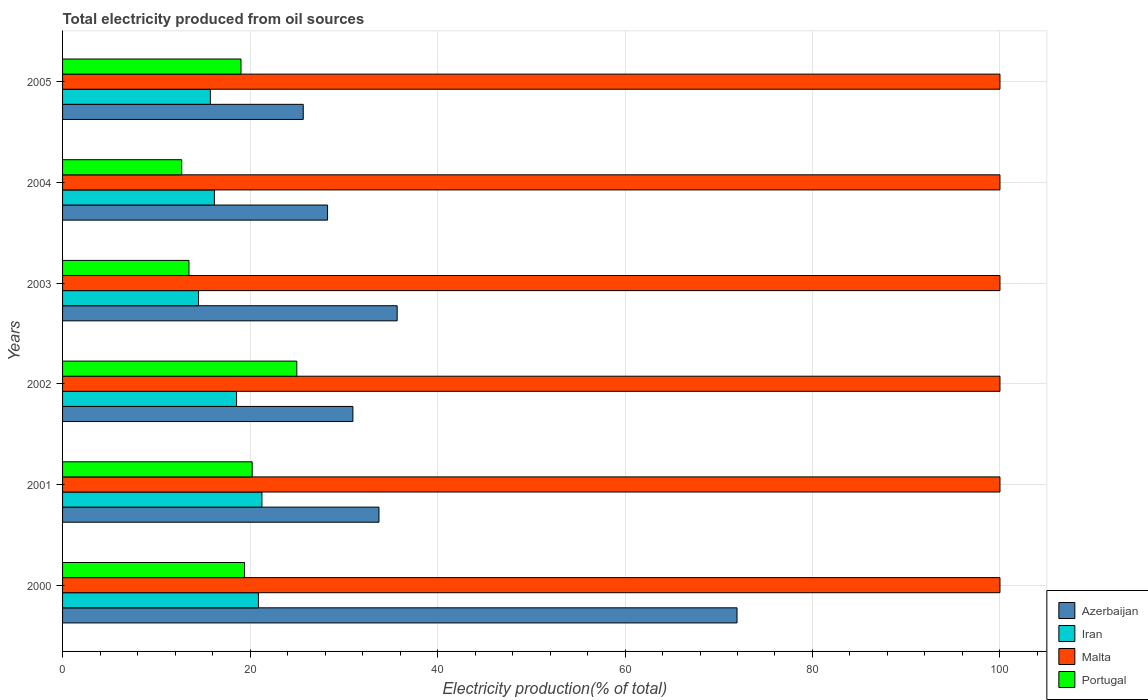How many different coloured bars are there?
Provide a succinct answer. 4. Are the number of bars per tick equal to the number of legend labels?
Offer a terse response. Yes. How many bars are there on the 5th tick from the top?
Provide a succinct answer. 4. In how many cases, is the number of bars for a given year not equal to the number of legend labels?
Your answer should be very brief. 0. What is the total electricity produced in Malta in 2004?
Offer a terse response. 100. Across all years, what is the maximum total electricity produced in Azerbaijan?
Offer a very short reply. 71.95. Across all years, what is the minimum total electricity produced in Malta?
Give a very brief answer. 100. In which year was the total electricity produced in Malta minimum?
Offer a terse response. 2000. What is the total total electricity produced in Malta in the graph?
Offer a very short reply. 600. What is the difference between the total electricity produced in Iran in 2002 and that in 2005?
Give a very brief answer. 2.8. What is the difference between the total electricity produced in Azerbaijan in 2003 and the total electricity produced in Iran in 2002?
Keep it short and to the point. 17.13. What is the average total electricity produced in Iran per year?
Provide a short and direct response. 17.87. In the year 2004, what is the difference between the total electricity produced in Portugal and total electricity produced in Malta?
Give a very brief answer. -87.29. In how many years, is the total electricity produced in Iran greater than 84 %?
Offer a very short reply. 0. What is the ratio of the total electricity produced in Portugal in 2001 to that in 2002?
Your answer should be compact. 0.81. What is the difference between the highest and the second highest total electricity produced in Malta?
Offer a terse response. 0. What is the difference between the highest and the lowest total electricity produced in Portugal?
Provide a succinct answer. 12.28. In how many years, is the total electricity produced in Portugal greater than the average total electricity produced in Portugal taken over all years?
Offer a very short reply. 4. Is the sum of the total electricity produced in Iran in 2000 and 2004 greater than the maximum total electricity produced in Malta across all years?
Give a very brief answer. No. Is it the case that in every year, the sum of the total electricity produced in Portugal and total electricity produced in Azerbaijan is greater than the sum of total electricity produced in Malta and total electricity produced in Iran?
Offer a very short reply. No. What does the 4th bar from the top in 2002 represents?
Ensure brevity in your answer.  Azerbaijan. What does the 1st bar from the bottom in 2002 represents?
Offer a terse response. Azerbaijan. Is it the case that in every year, the sum of the total electricity produced in Portugal and total electricity produced in Malta is greater than the total electricity produced in Azerbaijan?
Offer a very short reply. Yes. How many years are there in the graph?
Make the answer very short. 6. What is the difference between two consecutive major ticks on the X-axis?
Give a very brief answer. 20. Are the values on the major ticks of X-axis written in scientific E-notation?
Your response must be concise. No. Does the graph contain any zero values?
Provide a succinct answer. No. Does the graph contain grids?
Provide a short and direct response. Yes. How many legend labels are there?
Your answer should be compact. 4. What is the title of the graph?
Keep it short and to the point. Total electricity produced from oil sources. Does "High income: nonOECD" appear as one of the legend labels in the graph?
Offer a very short reply. No. What is the Electricity production(% of total) in Azerbaijan in 2000?
Make the answer very short. 71.95. What is the Electricity production(% of total) of Iran in 2000?
Offer a very short reply. 20.89. What is the Electricity production(% of total) of Portugal in 2000?
Your answer should be very brief. 19.42. What is the Electricity production(% of total) of Azerbaijan in 2001?
Your response must be concise. 33.75. What is the Electricity production(% of total) of Iran in 2001?
Your answer should be compact. 21.27. What is the Electricity production(% of total) in Malta in 2001?
Provide a short and direct response. 100. What is the Electricity production(% of total) in Portugal in 2001?
Give a very brief answer. 20.23. What is the Electricity production(% of total) in Azerbaijan in 2002?
Make the answer very short. 30.97. What is the Electricity production(% of total) of Iran in 2002?
Keep it short and to the point. 18.56. What is the Electricity production(% of total) in Malta in 2002?
Give a very brief answer. 100. What is the Electricity production(% of total) in Portugal in 2002?
Your answer should be very brief. 24.99. What is the Electricity production(% of total) in Azerbaijan in 2003?
Make the answer very short. 35.69. What is the Electricity production(% of total) of Iran in 2003?
Provide a short and direct response. 14.5. What is the Electricity production(% of total) of Malta in 2003?
Provide a short and direct response. 100. What is the Electricity production(% of total) of Portugal in 2003?
Make the answer very short. 13.48. What is the Electricity production(% of total) in Azerbaijan in 2004?
Give a very brief answer. 28.27. What is the Electricity production(% of total) of Iran in 2004?
Provide a succinct answer. 16.2. What is the Electricity production(% of total) in Portugal in 2004?
Give a very brief answer. 12.71. What is the Electricity production(% of total) of Azerbaijan in 2005?
Offer a terse response. 25.67. What is the Electricity production(% of total) in Iran in 2005?
Provide a short and direct response. 15.77. What is the Electricity production(% of total) in Malta in 2005?
Your answer should be compact. 100. What is the Electricity production(% of total) in Portugal in 2005?
Keep it short and to the point. 19.03. Across all years, what is the maximum Electricity production(% of total) in Azerbaijan?
Offer a very short reply. 71.95. Across all years, what is the maximum Electricity production(% of total) of Iran?
Provide a short and direct response. 21.27. Across all years, what is the maximum Electricity production(% of total) of Portugal?
Make the answer very short. 24.99. Across all years, what is the minimum Electricity production(% of total) of Azerbaijan?
Offer a terse response. 25.67. Across all years, what is the minimum Electricity production(% of total) of Iran?
Give a very brief answer. 14.5. Across all years, what is the minimum Electricity production(% of total) in Portugal?
Offer a very short reply. 12.71. What is the total Electricity production(% of total) of Azerbaijan in the graph?
Keep it short and to the point. 226.31. What is the total Electricity production(% of total) of Iran in the graph?
Make the answer very short. 107.19. What is the total Electricity production(% of total) in Malta in the graph?
Provide a short and direct response. 600. What is the total Electricity production(% of total) of Portugal in the graph?
Offer a terse response. 109.86. What is the difference between the Electricity production(% of total) in Azerbaijan in 2000 and that in 2001?
Your answer should be compact. 38.2. What is the difference between the Electricity production(% of total) in Iran in 2000 and that in 2001?
Give a very brief answer. -0.37. What is the difference between the Electricity production(% of total) in Malta in 2000 and that in 2001?
Your response must be concise. 0. What is the difference between the Electricity production(% of total) of Portugal in 2000 and that in 2001?
Provide a succinct answer. -0.81. What is the difference between the Electricity production(% of total) of Azerbaijan in 2000 and that in 2002?
Offer a very short reply. 40.98. What is the difference between the Electricity production(% of total) of Iran in 2000 and that in 2002?
Your answer should be compact. 2.33. What is the difference between the Electricity production(% of total) in Malta in 2000 and that in 2002?
Ensure brevity in your answer.  0. What is the difference between the Electricity production(% of total) in Portugal in 2000 and that in 2002?
Provide a short and direct response. -5.57. What is the difference between the Electricity production(% of total) in Azerbaijan in 2000 and that in 2003?
Keep it short and to the point. 36.26. What is the difference between the Electricity production(% of total) of Iran in 2000 and that in 2003?
Your response must be concise. 6.39. What is the difference between the Electricity production(% of total) of Portugal in 2000 and that in 2003?
Give a very brief answer. 5.93. What is the difference between the Electricity production(% of total) of Azerbaijan in 2000 and that in 2004?
Ensure brevity in your answer.  43.68. What is the difference between the Electricity production(% of total) of Iran in 2000 and that in 2004?
Your response must be concise. 4.7. What is the difference between the Electricity production(% of total) of Malta in 2000 and that in 2004?
Give a very brief answer. 0. What is the difference between the Electricity production(% of total) in Portugal in 2000 and that in 2004?
Your answer should be very brief. 6.7. What is the difference between the Electricity production(% of total) of Azerbaijan in 2000 and that in 2005?
Offer a terse response. 46.28. What is the difference between the Electricity production(% of total) in Iran in 2000 and that in 2005?
Provide a succinct answer. 5.13. What is the difference between the Electricity production(% of total) in Malta in 2000 and that in 2005?
Keep it short and to the point. 0. What is the difference between the Electricity production(% of total) in Portugal in 2000 and that in 2005?
Offer a terse response. 0.38. What is the difference between the Electricity production(% of total) in Azerbaijan in 2001 and that in 2002?
Your answer should be compact. 2.78. What is the difference between the Electricity production(% of total) in Iran in 2001 and that in 2002?
Your response must be concise. 2.7. What is the difference between the Electricity production(% of total) of Malta in 2001 and that in 2002?
Offer a terse response. 0. What is the difference between the Electricity production(% of total) of Portugal in 2001 and that in 2002?
Your answer should be compact. -4.76. What is the difference between the Electricity production(% of total) in Azerbaijan in 2001 and that in 2003?
Give a very brief answer. -1.94. What is the difference between the Electricity production(% of total) of Iran in 2001 and that in 2003?
Your response must be concise. 6.76. What is the difference between the Electricity production(% of total) in Malta in 2001 and that in 2003?
Ensure brevity in your answer.  0. What is the difference between the Electricity production(% of total) of Portugal in 2001 and that in 2003?
Offer a very short reply. 6.74. What is the difference between the Electricity production(% of total) in Azerbaijan in 2001 and that in 2004?
Make the answer very short. 5.48. What is the difference between the Electricity production(% of total) in Iran in 2001 and that in 2004?
Make the answer very short. 5.07. What is the difference between the Electricity production(% of total) in Portugal in 2001 and that in 2004?
Ensure brevity in your answer.  7.51. What is the difference between the Electricity production(% of total) in Azerbaijan in 2001 and that in 2005?
Make the answer very short. 8.08. What is the difference between the Electricity production(% of total) of Iran in 2001 and that in 2005?
Offer a very short reply. 5.5. What is the difference between the Electricity production(% of total) in Malta in 2001 and that in 2005?
Provide a succinct answer. 0. What is the difference between the Electricity production(% of total) in Portugal in 2001 and that in 2005?
Offer a terse response. 1.19. What is the difference between the Electricity production(% of total) of Azerbaijan in 2002 and that in 2003?
Keep it short and to the point. -4.72. What is the difference between the Electricity production(% of total) of Iran in 2002 and that in 2003?
Provide a short and direct response. 4.06. What is the difference between the Electricity production(% of total) in Portugal in 2002 and that in 2003?
Give a very brief answer. 11.5. What is the difference between the Electricity production(% of total) of Azerbaijan in 2002 and that in 2004?
Provide a short and direct response. 2.7. What is the difference between the Electricity production(% of total) in Iran in 2002 and that in 2004?
Provide a short and direct response. 2.37. What is the difference between the Electricity production(% of total) of Portugal in 2002 and that in 2004?
Offer a terse response. 12.28. What is the difference between the Electricity production(% of total) in Azerbaijan in 2002 and that in 2005?
Offer a terse response. 5.3. What is the difference between the Electricity production(% of total) of Iran in 2002 and that in 2005?
Your answer should be compact. 2.8. What is the difference between the Electricity production(% of total) of Portugal in 2002 and that in 2005?
Keep it short and to the point. 5.95. What is the difference between the Electricity production(% of total) in Azerbaijan in 2003 and that in 2004?
Offer a very short reply. 7.42. What is the difference between the Electricity production(% of total) in Iran in 2003 and that in 2004?
Give a very brief answer. -1.69. What is the difference between the Electricity production(% of total) in Portugal in 2003 and that in 2004?
Offer a very short reply. 0.77. What is the difference between the Electricity production(% of total) in Azerbaijan in 2003 and that in 2005?
Ensure brevity in your answer.  10.02. What is the difference between the Electricity production(% of total) of Iran in 2003 and that in 2005?
Your answer should be very brief. -1.26. What is the difference between the Electricity production(% of total) of Portugal in 2003 and that in 2005?
Your response must be concise. -5.55. What is the difference between the Electricity production(% of total) of Azerbaijan in 2004 and that in 2005?
Offer a terse response. 2.6. What is the difference between the Electricity production(% of total) in Iran in 2004 and that in 2005?
Ensure brevity in your answer.  0.43. What is the difference between the Electricity production(% of total) in Portugal in 2004 and that in 2005?
Your answer should be very brief. -6.32. What is the difference between the Electricity production(% of total) in Azerbaijan in 2000 and the Electricity production(% of total) in Iran in 2001?
Offer a very short reply. 50.68. What is the difference between the Electricity production(% of total) in Azerbaijan in 2000 and the Electricity production(% of total) in Malta in 2001?
Offer a very short reply. -28.05. What is the difference between the Electricity production(% of total) in Azerbaijan in 2000 and the Electricity production(% of total) in Portugal in 2001?
Provide a succinct answer. 51.72. What is the difference between the Electricity production(% of total) in Iran in 2000 and the Electricity production(% of total) in Malta in 2001?
Offer a very short reply. -79.11. What is the difference between the Electricity production(% of total) in Iran in 2000 and the Electricity production(% of total) in Portugal in 2001?
Keep it short and to the point. 0.67. What is the difference between the Electricity production(% of total) in Malta in 2000 and the Electricity production(% of total) in Portugal in 2001?
Your response must be concise. 79.77. What is the difference between the Electricity production(% of total) of Azerbaijan in 2000 and the Electricity production(% of total) of Iran in 2002?
Make the answer very short. 53.39. What is the difference between the Electricity production(% of total) in Azerbaijan in 2000 and the Electricity production(% of total) in Malta in 2002?
Your response must be concise. -28.05. What is the difference between the Electricity production(% of total) in Azerbaijan in 2000 and the Electricity production(% of total) in Portugal in 2002?
Offer a very short reply. 46.96. What is the difference between the Electricity production(% of total) of Iran in 2000 and the Electricity production(% of total) of Malta in 2002?
Your response must be concise. -79.11. What is the difference between the Electricity production(% of total) of Iran in 2000 and the Electricity production(% of total) of Portugal in 2002?
Offer a terse response. -4.09. What is the difference between the Electricity production(% of total) in Malta in 2000 and the Electricity production(% of total) in Portugal in 2002?
Offer a terse response. 75.01. What is the difference between the Electricity production(% of total) of Azerbaijan in 2000 and the Electricity production(% of total) of Iran in 2003?
Provide a short and direct response. 57.45. What is the difference between the Electricity production(% of total) in Azerbaijan in 2000 and the Electricity production(% of total) in Malta in 2003?
Offer a very short reply. -28.05. What is the difference between the Electricity production(% of total) of Azerbaijan in 2000 and the Electricity production(% of total) of Portugal in 2003?
Give a very brief answer. 58.47. What is the difference between the Electricity production(% of total) in Iran in 2000 and the Electricity production(% of total) in Malta in 2003?
Offer a terse response. -79.11. What is the difference between the Electricity production(% of total) in Iran in 2000 and the Electricity production(% of total) in Portugal in 2003?
Offer a very short reply. 7.41. What is the difference between the Electricity production(% of total) of Malta in 2000 and the Electricity production(% of total) of Portugal in 2003?
Offer a terse response. 86.52. What is the difference between the Electricity production(% of total) of Azerbaijan in 2000 and the Electricity production(% of total) of Iran in 2004?
Keep it short and to the point. 55.75. What is the difference between the Electricity production(% of total) of Azerbaijan in 2000 and the Electricity production(% of total) of Malta in 2004?
Offer a very short reply. -28.05. What is the difference between the Electricity production(% of total) in Azerbaijan in 2000 and the Electricity production(% of total) in Portugal in 2004?
Your answer should be very brief. 59.24. What is the difference between the Electricity production(% of total) of Iran in 2000 and the Electricity production(% of total) of Malta in 2004?
Provide a short and direct response. -79.11. What is the difference between the Electricity production(% of total) in Iran in 2000 and the Electricity production(% of total) in Portugal in 2004?
Provide a succinct answer. 8.18. What is the difference between the Electricity production(% of total) of Malta in 2000 and the Electricity production(% of total) of Portugal in 2004?
Make the answer very short. 87.29. What is the difference between the Electricity production(% of total) of Azerbaijan in 2000 and the Electricity production(% of total) of Iran in 2005?
Provide a short and direct response. 56.18. What is the difference between the Electricity production(% of total) of Azerbaijan in 2000 and the Electricity production(% of total) of Malta in 2005?
Make the answer very short. -28.05. What is the difference between the Electricity production(% of total) of Azerbaijan in 2000 and the Electricity production(% of total) of Portugal in 2005?
Provide a short and direct response. 52.92. What is the difference between the Electricity production(% of total) in Iran in 2000 and the Electricity production(% of total) in Malta in 2005?
Give a very brief answer. -79.11. What is the difference between the Electricity production(% of total) of Iran in 2000 and the Electricity production(% of total) of Portugal in 2005?
Give a very brief answer. 1.86. What is the difference between the Electricity production(% of total) of Malta in 2000 and the Electricity production(% of total) of Portugal in 2005?
Give a very brief answer. 80.97. What is the difference between the Electricity production(% of total) of Azerbaijan in 2001 and the Electricity production(% of total) of Iran in 2002?
Your response must be concise. 15.19. What is the difference between the Electricity production(% of total) of Azerbaijan in 2001 and the Electricity production(% of total) of Malta in 2002?
Offer a terse response. -66.25. What is the difference between the Electricity production(% of total) in Azerbaijan in 2001 and the Electricity production(% of total) in Portugal in 2002?
Provide a succinct answer. 8.77. What is the difference between the Electricity production(% of total) of Iran in 2001 and the Electricity production(% of total) of Malta in 2002?
Keep it short and to the point. -78.73. What is the difference between the Electricity production(% of total) of Iran in 2001 and the Electricity production(% of total) of Portugal in 2002?
Offer a terse response. -3.72. What is the difference between the Electricity production(% of total) of Malta in 2001 and the Electricity production(% of total) of Portugal in 2002?
Your answer should be very brief. 75.01. What is the difference between the Electricity production(% of total) in Azerbaijan in 2001 and the Electricity production(% of total) in Iran in 2003?
Offer a very short reply. 19.25. What is the difference between the Electricity production(% of total) of Azerbaijan in 2001 and the Electricity production(% of total) of Malta in 2003?
Your response must be concise. -66.25. What is the difference between the Electricity production(% of total) in Azerbaijan in 2001 and the Electricity production(% of total) in Portugal in 2003?
Give a very brief answer. 20.27. What is the difference between the Electricity production(% of total) of Iran in 2001 and the Electricity production(% of total) of Malta in 2003?
Provide a succinct answer. -78.73. What is the difference between the Electricity production(% of total) in Iran in 2001 and the Electricity production(% of total) in Portugal in 2003?
Provide a short and direct response. 7.78. What is the difference between the Electricity production(% of total) of Malta in 2001 and the Electricity production(% of total) of Portugal in 2003?
Make the answer very short. 86.52. What is the difference between the Electricity production(% of total) in Azerbaijan in 2001 and the Electricity production(% of total) in Iran in 2004?
Offer a very short reply. 17.56. What is the difference between the Electricity production(% of total) of Azerbaijan in 2001 and the Electricity production(% of total) of Malta in 2004?
Provide a succinct answer. -66.25. What is the difference between the Electricity production(% of total) of Azerbaijan in 2001 and the Electricity production(% of total) of Portugal in 2004?
Keep it short and to the point. 21.04. What is the difference between the Electricity production(% of total) in Iran in 2001 and the Electricity production(% of total) in Malta in 2004?
Give a very brief answer. -78.73. What is the difference between the Electricity production(% of total) of Iran in 2001 and the Electricity production(% of total) of Portugal in 2004?
Your answer should be very brief. 8.56. What is the difference between the Electricity production(% of total) of Malta in 2001 and the Electricity production(% of total) of Portugal in 2004?
Ensure brevity in your answer.  87.29. What is the difference between the Electricity production(% of total) of Azerbaijan in 2001 and the Electricity production(% of total) of Iran in 2005?
Your answer should be compact. 17.99. What is the difference between the Electricity production(% of total) of Azerbaijan in 2001 and the Electricity production(% of total) of Malta in 2005?
Offer a very short reply. -66.25. What is the difference between the Electricity production(% of total) in Azerbaijan in 2001 and the Electricity production(% of total) in Portugal in 2005?
Offer a very short reply. 14.72. What is the difference between the Electricity production(% of total) of Iran in 2001 and the Electricity production(% of total) of Malta in 2005?
Provide a short and direct response. -78.73. What is the difference between the Electricity production(% of total) of Iran in 2001 and the Electricity production(% of total) of Portugal in 2005?
Provide a succinct answer. 2.23. What is the difference between the Electricity production(% of total) of Malta in 2001 and the Electricity production(% of total) of Portugal in 2005?
Offer a very short reply. 80.97. What is the difference between the Electricity production(% of total) of Azerbaijan in 2002 and the Electricity production(% of total) of Iran in 2003?
Your answer should be very brief. 16.47. What is the difference between the Electricity production(% of total) of Azerbaijan in 2002 and the Electricity production(% of total) of Malta in 2003?
Keep it short and to the point. -69.03. What is the difference between the Electricity production(% of total) in Azerbaijan in 2002 and the Electricity production(% of total) in Portugal in 2003?
Make the answer very short. 17.49. What is the difference between the Electricity production(% of total) in Iran in 2002 and the Electricity production(% of total) in Malta in 2003?
Keep it short and to the point. -81.44. What is the difference between the Electricity production(% of total) in Iran in 2002 and the Electricity production(% of total) in Portugal in 2003?
Offer a very short reply. 5.08. What is the difference between the Electricity production(% of total) of Malta in 2002 and the Electricity production(% of total) of Portugal in 2003?
Make the answer very short. 86.52. What is the difference between the Electricity production(% of total) in Azerbaijan in 2002 and the Electricity production(% of total) in Iran in 2004?
Offer a terse response. 14.78. What is the difference between the Electricity production(% of total) in Azerbaijan in 2002 and the Electricity production(% of total) in Malta in 2004?
Offer a terse response. -69.03. What is the difference between the Electricity production(% of total) in Azerbaijan in 2002 and the Electricity production(% of total) in Portugal in 2004?
Offer a terse response. 18.26. What is the difference between the Electricity production(% of total) in Iran in 2002 and the Electricity production(% of total) in Malta in 2004?
Keep it short and to the point. -81.44. What is the difference between the Electricity production(% of total) in Iran in 2002 and the Electricity production(% of total) in Portugal in 2004?
Offer a very short reply. 5.85. What is the difference between the Electricity production(% of total) in Malta in 2002 and the Electricity production(% of total) in Portugal in 2004?
Offer a terse response. 87.29. What is the difference between the Electricity production(% of total) in Azerbaijan in 2002 and the Electricity production(% of total) in Iran in 2005?
Make the answer very short. 15.21. What is the difference between the Electricity production(% of total) in Azerbaijan in 2002 and the Electricity production(% of total) in Malta in 2005?
Your answer should be compact. -69.03. What is the difference between the Electricity production(% of total) of Azerbaijan in 2002 and the Electricity production(% of total) of Portugal in 2005?
Ensure brevity in your answer.  11.94. What is the difference between the Electricity production(% of total) of Iran in 2002 and the Electricity production(% of total) of Malta in 2005?
Give a very brief answer. -81.44. What is the difference between the Electricity production(% of total) of Iran in 2002 and the Electricity production(% of total) of Portugal in 2005?
Offer a terse response. -0.47. What is the difference between the Electricity production(% of total) of Malta in 2002 and the Electricity production(% of total) of Portugal in 2005?
Your response must be concise. 80.97. What is the difference between the Electricity production(% of total) of Azerbaijan in 2003 and the Electricity production(% of total) of Iran in 2004?
Ensure brevity in your answer.  19.5. What is the difference between the Electricity production(% of total) of Azerbaijan in 2003 and the Electricity production(% of total) of Malta in 2004?
Ensure brevity in your answer.  -64.31. What is the difference between the Electricity production(% of total) in Azerbaijan in 2003 and the Electricity production(% of total) in Portugal in 2004?
Provide a short and direct response. 22.98. What is the difference between the Electricity production(% of total) in Iran in 2003 and the Electricity production(% of total) in Malta in 2004?
Provide a short and direct response. -85.5. What is the difference between the Electricity production(% of total) in Iran in 2003 and the Electricity production(% of total) in Portugal in 2004?
Make the answer very short. 1.79. What is the difference between the Electricity production(% of total) in Malta in 2003 and the Electricity production(% of total) in Portugal in 2004?
Provide a short and direct response. 87.29. What is the difference between the Electricity production(% of total) in Azerbaijan in 2003 and the Electricity production(% of total) in Iran in 2005?
Your answer should be compact. 19.93. What is the difference between the Electricity production(% of total) in Azerbaijan in 2003 and the Electricity production(% of total) in Malta in 2005?
Your answer should be very brief. -64.31. What is the difference between the Electricity production(% of total) in Azerbaijan in 2003 and the Electricity production(% of total) in Portugal in 2005?
Give a very brief answer. 16.66. What is the difference between the Electricity production(% of total) of Iran in 2003 and the Electricity production(% of total) of Malta in 2005?
Ensure brevity in your answer.  -85.5. What is the difference between the Electricity production(% of total) of Iran in 2003 and the Electricity production(% of total) of Portugal in 2005?
Ensure brevity in your answer.  -4.53. What is the difference between the Electricity production(% of total) in Malta in 2003 and the Electricity production(% of total) in Portugal in 2005?
Make the answer very short. 80.97. What is the difference between the Electricity production(% of total) in Azerbaijan in 2004 and the Electricity production(% of total) in Iran in 2005?
Offer a very short reply. 12.5. What is the difference between the Electricity production(% of total) of Azerbaijan in 2004 and the Electricity production(% of total) of Malta in 2005?
Offer a very short reply. -71.73. What is the difference between the Electricity production(% of total) in Azerbaijan in 2004 and the Electricity production(% of total) in Portugal in 2005?
Provide a short and direct response. 9.24. What is the difference between the Electricity production(% of total) in Iran in 2004 and the Electricity production(% of total) in Malta in 2005?
Your answer should be compact. -83.8. What is the difference between the Electricity production(% of total) in Iran in 2004 and the Electricity production(% of total) in Portugal in 2005?
Provide a succinct answer. -2.84. What is the difference between the Electricity production(% of total) of Malta in 2004 and the Electricity production(% of total) of Portugal in 2005?
Provide a succinct answer. 80.97. What is the average Electricity production(% of total) of Azerbaijan per year?
Offer a very short reply. 37.72. What is the average Electricity production(% of total) in Iran per year?
Offer a terse response. 17.87. What is the average Electricity production(% of total) of Portugal per year?
Ensure brevity in your answer.  18.31. In the year 2000, what is the difference between the Electricity production(% of total) in Azerbaijan and Electricity production(% of total) in Iran?
Keep it short and to the point. 51.06. In the year 2000, what is the difference between the Electricity production(% of total) in Azerbaijan and Electricity production(% of total) in Malta?
Make the answer very short. -28.05. In the year 2000, what is the difference between the Electricity production(% of total) in Azerbaijan and Electricity production(% of total) in Portugal?
Your response must be concise. 52.53. In the year 2000, what is the difference between the Electricity production(% of total) in Iran and Electricity production(% of total) in Malta?
Offer a terse response. -79.11. In the year 2000, what is the difference between the Electricity production(% of total) in Iran and Electricity production(% of total) in Portugal?
Your response must be concise. 1.48. In the year 2000, what is the difference between the Electricity production(% of total) in Malta and Electricity production(% of total) in Portugal?
Offer a very short reply. 80.58. In the year 2001, what is the difference between the Electricity production(% of total) of Azerbaijan and Electricity production(% of total) of Iran?
Offer a very short reply. 12.49. In the year 2001, what is the difference between the Electricity production(% of total) in Azerbaijan and Electricity production(% of total) in Malta?
Your answer should be compact. -66.25. In the year 2001, what is the difference between the Electricity production(% of total) in Azerbaijan and Electricity production(% of total) in Portugal?
Offer a terse response. 13.53. In the year 2001, what is the difference between the Electricity production(% of total) of Iran and Electricity production(% of total) of Malta?
Ensure brevity in your answer.  -78.73. In the year 2001, what is the difference between the Electricity production(% of total) of Iran and Electricity production(% of total) of Portugal?
Make the answer very short. 1.04. In the year 2001, what is the difference between the Electricity production(% of total) in Malta and Electricity production(% of total) in Portugal?
Your response must be concise. 79.77. In the year 2002, what is the difference between the Electricity production(% of total) in Azerbaijan and Electricity production(% of total) in Iran?
Your answer should be compact. 12.41. In the year 2002, what is the difference between the Electricity production(% of total) of Azerbaijan and Electricity production(% of total) of Malta?
Provide a succinct answer. -69.03. In the year 2002, what is the difference between the Electricity production(% of total) of Azerbaijan and Electricity production(% of total) of Portugal?
Offer a terse response. 5.98. In the year 2002, what is the difference between the Electricity production(% of total) of Iran and Electricity production(% of total) of Malta?
Offer a very short reply. -81.44. In the year 2002, what is the difference between the Electricity production(% of total) of Iran and Electricity production(% of total) of Portugal?
Your answer should be very brief. -6.43. In the year 2002, what is the difference between the Electricity production(% of total) in Malta and Electricity production(% of total) in Portugal?
Your answer should be very brief. 75.01. In the year 2003, what is the difference between the Electricity production(% of total) of Azerbaijan and Electricity production(% of total) of Iran?
Offer a very short reply. 21.19. In the year 2003, what is the difference between the Electricity production(% of total) of Azerbaijan and Electricity production(% of total) of Malta?
Your answer should be compact. -64.31. In the year 2003, what is the difference between the Electricity production(% of total) in Azerbaijan and Electricity production(% of total) in Portugal?
Ensure brevity in your answer.  22.21. In the year 2003, what is the difference between the Electricity production(% of total) of Iran and Electricity production(% of total) of Malta?
Offer a terse response. -85.5. In the year 2003, what is the difference between the Electricity production(% of total) in Iran and Electricity production(% of total) in Portugal?
Provide a short and direct response. 1.02. In the year 2003, what is the difference between the Electricity production(% of total) of Malta and Electricity production(% of total) of Portugal?
Keep it short and to the point. 86.52. In the year 2004, what is the difference between the Electricity production(% of total) in Azerbaijan and Electricity production(% of total) in Iran?
Provide a short and direct response. 12.07. In the year 2004, what is the difference between the Electricity production(% of total) of Azerbaijan and Electricity production(% of total) of Malta?
Provide a short and direct response. -71.73. In the year 2004, what is the difference between the Electricity production(% of total) in Azerbaijan and Electricity production(% of total) in Portugal?
Keep it short and to the point. 15.56. In the year 2004, what is the difference between the Electricity production(% of total) in Iran and Electricity production(% of total) in Malta?
Offer a terse response. -83.8. In the year 2004, what is the difference between the Electricity production(% of total) in Iran and Electricity production(% of total) in Portugal?
Offer a terse response. 3.49. In the year 2004, what is the difference between the Electricity production(% of total) of Malta and Electricity production(% of total) of Portugal?
Keep it short and to the point. 87.29. In the year 2005, what is the difference between the Electricity production(% of total) of Azerbaijan and Electricity production(% of total) of Iran?
Your answer should be very brief. 9.91. In the year 2005, what is the difference between the Electricity production(% of total) of Azerbaijan and Electricity production(% of total) of Malta?
Offer a very short reply. -74.33. In the year 2005, what is the difference between the Electricity production(% of total) in Azerbaijan and Electricity production(% of total) in Portugal?
Offer a very short reply. 6.64. In the year 2005, what is the difference between the Electricity production(% of total) of Iran and Electricity production(% of total) of Malta?
Your answer should be compact. -84.23. In the year 2005, what is the difference between the Electricity production(% of total) in Iran and Electricity production(% of total) in Portugal?
Your answer should be compact. -3.27. In the year 2005, what is the difference between the Electricity production(% of total) of Malta and Electricity production(% of total) of Portugal?
Your response must be concise. 80.97. What is the ratio of the Electricity production(% of total) in Azerbaijan in 2000 to that in 2001?
Ensure brevity in your answer.  2.13. What is the ratio of the Electricity production(% of total) in Iran in 2000 to that in 2001?
Your answer should be compact. 0.98. What is the ratio of the Electricity production(% of total) of Portugal in 2000 to that in 2001?
Your answer should be compact. 0.96. What is the ratio of the Electricity production(% of total) of Azerbaijan in 2000 to that in 2002?
Give a very brief answer. 2.32. What is the ratio of the Electricity production(% of total) in Iran in 2000 to that in 2002?
Offer a very short reply. 1.13. What is the ratio of the Electricity production(% of total) of Malta in 2000 to that in 2002?
Your response must be concise. 1. What is the ratio of the Electricity production(% of total) in Portugal in 2000 to that in 2002?
Your answer should be very brief. 0.78. What is the ratio of the Electricity production(% of total) of Azerbaijan in 2000 to that in 2003?
Provide a succinct answer. 2.02. What is the ratio of the Electricity production(% of total) in Iran in 2000 to that in 2003?
Ensure brevity in your answer.  1.44. What is the ratio of the Electricity production(% of total) in Portugal in 2000 to that in 2003?
Offer a terse response. 1.44. What is the ratio of the Electricity production(% of total) in Azerbaijan in 2000 to that in 2004?
Keep it short and to the point. 2.55. What is the ratio of the Electricity production(% of total) in Iran in 2000 to that in 2004?
Your response must be concise. 1.29. What is the ratio of the Electricity production(% of total) in Malta in 2000 to that in 2004?
Keep it short and to the point. 1. What is the ratio of the Electricity production(% of total) of Portugal in 2000 to that in 2004?
Give a very brief answer. 1.53. What is the ratio of the Electricity production(% of total) of Azerbaijan in 2000 to that in 2005?
Keep it short and to the point. 2.8. What is the ratio of the Electricity production(% of total) of Iran in 2000 to that in 2005?
Provide a short and direct response. 1.33. What is the ratio of the Electricity production(% of total) of Malta in 2000 to that in 2005?
Your answer should be very brief. 1. What is the ratio of the Electricity production(% of total) in Portugal in 2000 to that in 2005?
Give a very brief answer. 1.02. What is the ratio of the Electricity production(% of total) in Azerbaijan in 2001 to that in 2002?
Your answer should be very brief. 1.09. What is the ratio of the Electricity production(% of total) in Iran in 2001 to that in 2002?
Give a very brief answer. 1.15. What is the ratio of the Electricity production(% of total) of Malta in 2001 to that in 2002?
Give a very brief answer. 1. What is the ratio of the Electricity production(% of total) in Portugal in 2001 to that in 2002?
Ensure brevity in your answer.  0.81. What is the ratio of the Electricity production(% of total) in Azerbaijan in 2001 to that in 2003?
Your answer should be compact. 0.95. What is the ratio of the Electricity production(% of total) of Iran in 2001 to that in 2003?
Keep it short and to the point. 1.47. What is the ratio of the Electricity production(% of total) of Malta in 2001 to that in 2003?
Offer a terse response. 1. What is the ratio of the Electricity production(% of total) in Portugal in 2001 to that in 2003?
Your response must be concise. 1.5. What is the ratio of the Electricity production(% of total) in Azerbaijan in 2001 to that in 2004?
Keep it short and to the point. 1.19. What is the ratio of the Electricity production(% of total) in Iran in 2001 to that in 2004?
Your response must be concise. 1.31. What is the ratio of the Electricity production(% of total) in Portugal in 2001 to that in 2004?
Provide a short and direct response. 1.59. What is the ratio of the Electricity production(% of total) in Azerbaijan in 2001 to that in 2005?
Provide a succinct answer. 1.31. What is the ratio of the Electricity production(% of total) of Iran in 2001 to that in 2005?
Ensure brevity in your answer.  1.35. What is the ratio of the Electricity production(% of total) in Portugal in 2001 to that in 2005?
Offer a terse response. 1.06. What is the ratio of the Electricity production(% of total) in Azerbaijan in 2002 to that in 2003?
Make the answer very short. 0.87. What is the ratio of the Electricity production(% of total) of Iran in 2002 to that in 2003?
Your answer should be compact. 1.28. What is the ratio of the Electricity production(% of total) of Portugal in 2002 to that in 2003?
Your answer should be compact. 1.85. What is the ratio of the Electricity production(% of total) in Azerbaijan in 2002 to that in 2004?
Keep it short and to the point. 1.1. What is the ratio of the Electricity production(% of total) in Iran in 2002 to that in 2004?
Make the answer very short. 1.15. What is the ratio of the Electricity production(% of total) of Portugal in 2002 to that in 2004?
Your response must be concise. 1.97. What is the ratio of the Electricity production(% of total) in Azerbaijan in 2002 to that in 2005?
Ensure brevity in your answer.  1.21. What is the ratio of the Electricity production(% of total) of Iran in 2002 to that in 2005?
Your response must be concise. 1.18. What is the ratio of the Electricity production(% of total) in Malta in 2002 to that in 2005?
Provide a succinct answer. 1. What is the ratio of the Electricity production(% of total) of Portugal in 2002 to that in 2005?
Your response must be concise. 1.31. What is the ratio of the Electricity production(% of total) in Azerbaijan in 2003 to that in 2004?
Keep it short and to the point. 1.26. What is the ratio of the Electricity production(% of total) of Iran in 2003 to that in 2004?
Offer a terse response. 0.9. What is the ratio of the Electricity production(% of total) of Malta in 2003 to that in 2004?
Offer a terse response. 1. What is the ratio of the Electricity production(% of total) of Portugal in 2003 to that in 2004?
Your response must be concise. 1.06. What is the ratio of the Electricity production(% of total) of Azerbaijan in 2003 to that in 2005?
Give a very brief answer. 1.39. What is the ratio of the Electricity production(% of total) of Iran in 2003 to that in 2005?
Ensure brevity in your answer.  0.92. What is the ratio of the Electricity production(% of total) in Portugal in 2003 to that in 2005?
Keep it short and to the point. 0.71. What is the ratio of the Electricity production(% of total) of Azerbaijan in 2004 to that in 2005?
Keep it short and to the point. 1.1. What is the ratio of the Electricity production(% of total) in Iran in 2004 to that in 2005?
Your response must be concise. 1.03. What is the ratio of the Electricity production(% of total) in Portugal in 2004 to that in 2005?
Keep it short and to the point. 0.67. What is the difference between the highest and the second highest Electricity production(% of total) of Azerbaijan?
Your answer should be very brief. 36.26. What is the difference between the highest and the second highest Electricity production(% of total) of Iran?
Your answer should be very brief. 0.37. What is the difference between the highest and the second highest Electricity production(% of total) of Malta?
Provide a succinct answer. 0. What is the difference between the highest and the second highest Electricity production(% of total) in Portugal?
Offer a very short reply. 4.76. What is the difference between the highest and the lowest Electricity production(% of total) of Azerbaijan?
Keep it short and to the point. 46.28. What is the difference between the highest and the lowest Electricity production(% of total) in Iran?
Keep it short and to the point. 6.76. What is the difference between the highest and the lowest Electricity production(% of total) in Malta?
Make the answer very short. 0. What is the difference between the highest and the lowest Electricity production(% of total) of Portugal?
Keep it short and to the point. 12.28. 